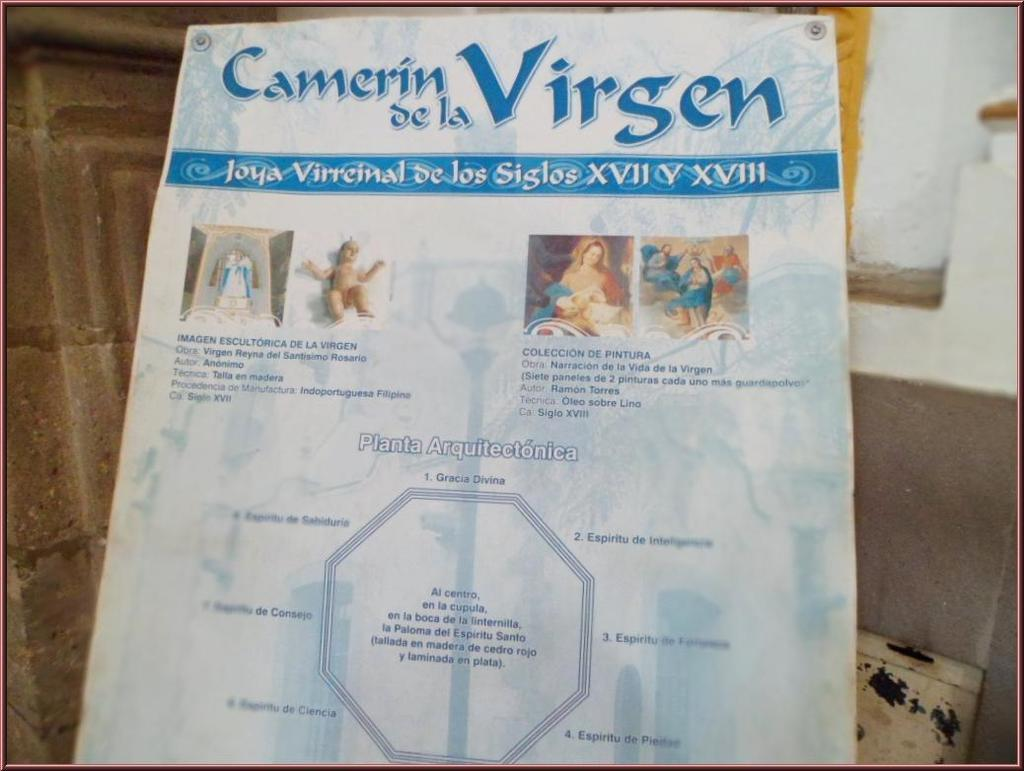What is the main subject in the middle of the image? There is a poster in the middle of the image. What can be seen in the background of the image? There is a wall in the background of the image. Can you see a kitten playing in the rainstorm through the window in the image? There is no window or kitten playing in the rainstorm present in the image. 